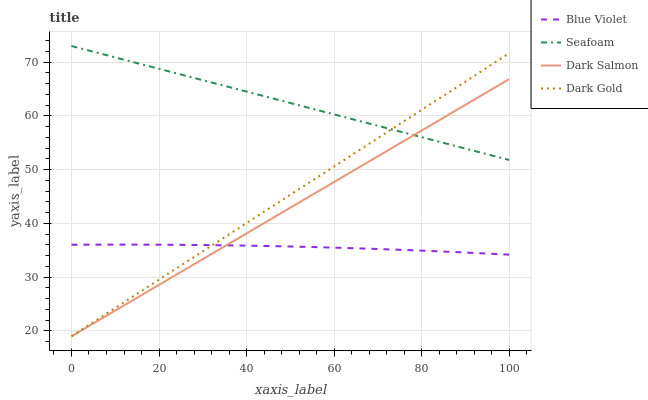Does Blue Violet have the minimum area under the curve?
Answer yes or no. Yes. Does Seafoam have the maximum area under the curve?
Answer yes or no. Yes. Does Seafoam have the minimum area under the curve?
Answer yes or no. No. Does Blue Violet have the maximum area under the curve?
Answer yes or no. No. Is Dark Salmon the smoothest?
Answer yes or no. Yes. Is Blue Violet the roughest?
Answer yes or no. Yes. Is Seafoam the smoothest?
Answer yes or no. No. Is Seafoam the roughest?
Answer yes or no. No. Does Dark Gold have the lowest value?
Answer yes or no. Yes. Does Blue Violet have the lowest value?
Answer yes or no. No. Does Seafoam have the highest value?
Answer yes or no. Yes. Does Blue Violet have the highest value?
Answer yes or no. No. Is Blue Violet less than Seafoam?
Answer yes or no. Yes. Is Seafoam greater than Blue Violet?
Answer yes or no. Yes. Does Dark Gold intersect Seafoam?
Answer yes or no. Yes. Is Dark Gold less than Seafoam?
Answer yes or no. No. Is Dark Gold greater than Seafoam?
Answer yes or no. No. Does Blue Violet intersect Seafoam?
Answer yes or no. No. 